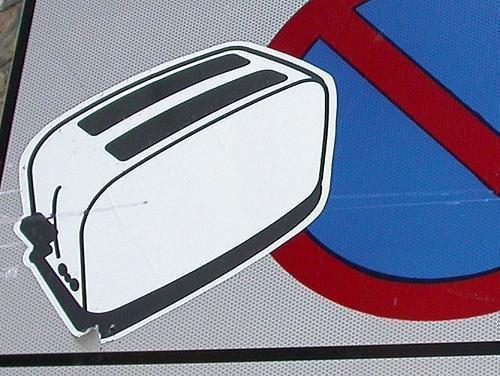How many toast can you make at once?
Give a very brief answer. 2. How many people do you see?
Give a very brief answer. 0. 